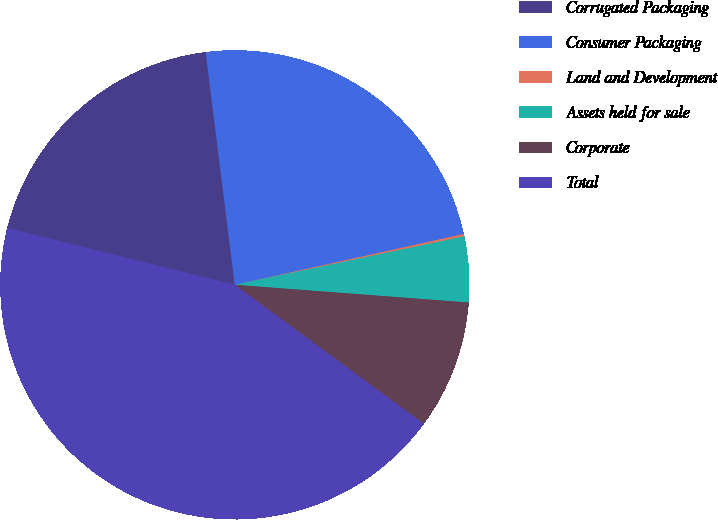<chart> <loc_0><loc_0><loc_500><loc_500><pie_chart><fcel>Corrugated Packaging<fcel>Consumer Packaging<fcel>Land and Development<fcel>Assets held for sale<fcel>Corporate<fcel>Total<nl><fcel>19.13%<fcel>23.5%<fcel>0.16%<fcel>4.52%<fcel>8.89%<fcel>43.8%<nl></chart> 